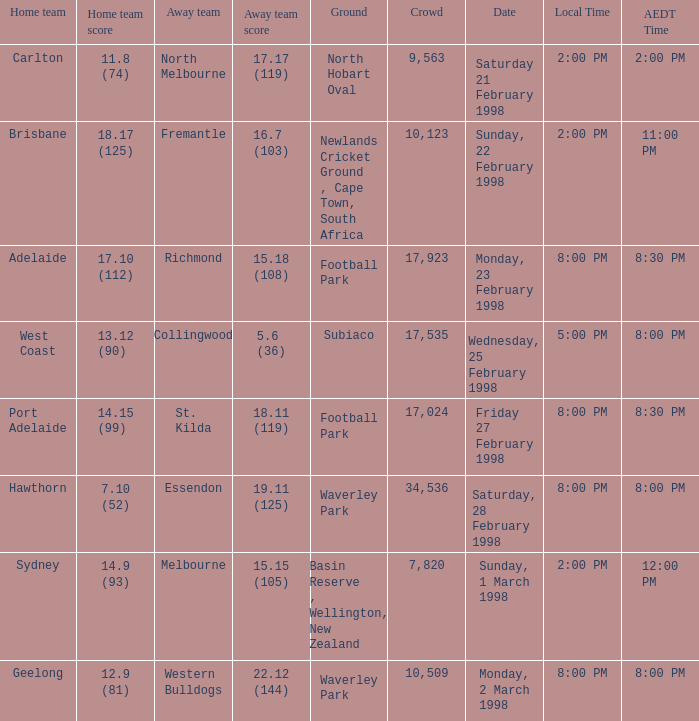Can you give me this table as a dict? {'header': ['Home team', 'Home team score', 'Away team', 'Away team score', 'Ground', 'Crowd', 'Date', 'Local Time', 'AEDT Time'], 'rows': [['Carlton', '11.8 (74)', 'North Melbourne', '17.17 (119)', 'North Hobart Oval', '9,563', 'Saturday 21 February 1998', '2:00 PM', '2:00 PM'], ['Brisbane', '18.17 (125)', 'Fremantle', '16.7 (103)', 'Newlands Cricket Ground , Cape Town, South Africa', '10,123', 'Sunday, 22 February 1998', '2:00 PM', '11:00 PM'], ['Adelaide', '17.10 (112)', 'Richmond', '15.18 (108)', 'Football Park', '17,923', 'Monday, 23 February 1998', '8:00 PM', '8:30 PM'], ['West Coast', '13.12 (90)', 'Collingwood', '5.6 (36)', 'Subiaco', '17,535', 'Wednesday, 25 February 1998', '5:00 PM', '8:00 PM'], ['Port Adelaide', '14.15 (99)', 'St. Kilda', '18.11 (119)', 'Football Park', '17,024', 'Friday 27 February 1998', '8:00 PM', '8:30 PM'], ['Hawthorn', '7.10 (52)', 'Essendon', '19.11 (125)', 'Waverley Park', '34,536', 'Saturday, 28 February 1998', '8:00 PM', '8:00 PM'], ['Sydney', '14.9 (93)', 'Melbourne', '15.15 (105)', 'Basin Reserve , Wellington, New Zealand', '7,820', 'Sunday, 1 March 1998', '2:00 PM', '12:00 PM'], ['Geelong', '12.9 (81)', 'Western Bulldogs', '22.12 (144)', 'Waverley Park', '10,509', 'Monday, 2 March 1998', '8:00 PM', '8:00 PM']]} What is the home team's score at an aedt time of 11:00 pm? 18.17 (125). 